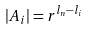<formula> <loc_0><loc_0><loc_500><loc_500>| A _ { i } | = r ^ { l _ { n } - l _ { i } }</formula> 